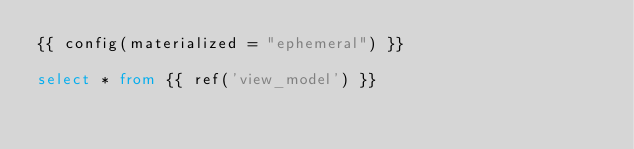Convert code to text. <code><loc_0><loc_0><loc_500><loc_500><_SQL_>{{ config(materialized = "ephemeral") }}

select * from {{ ref('view_model') }}
</code> 